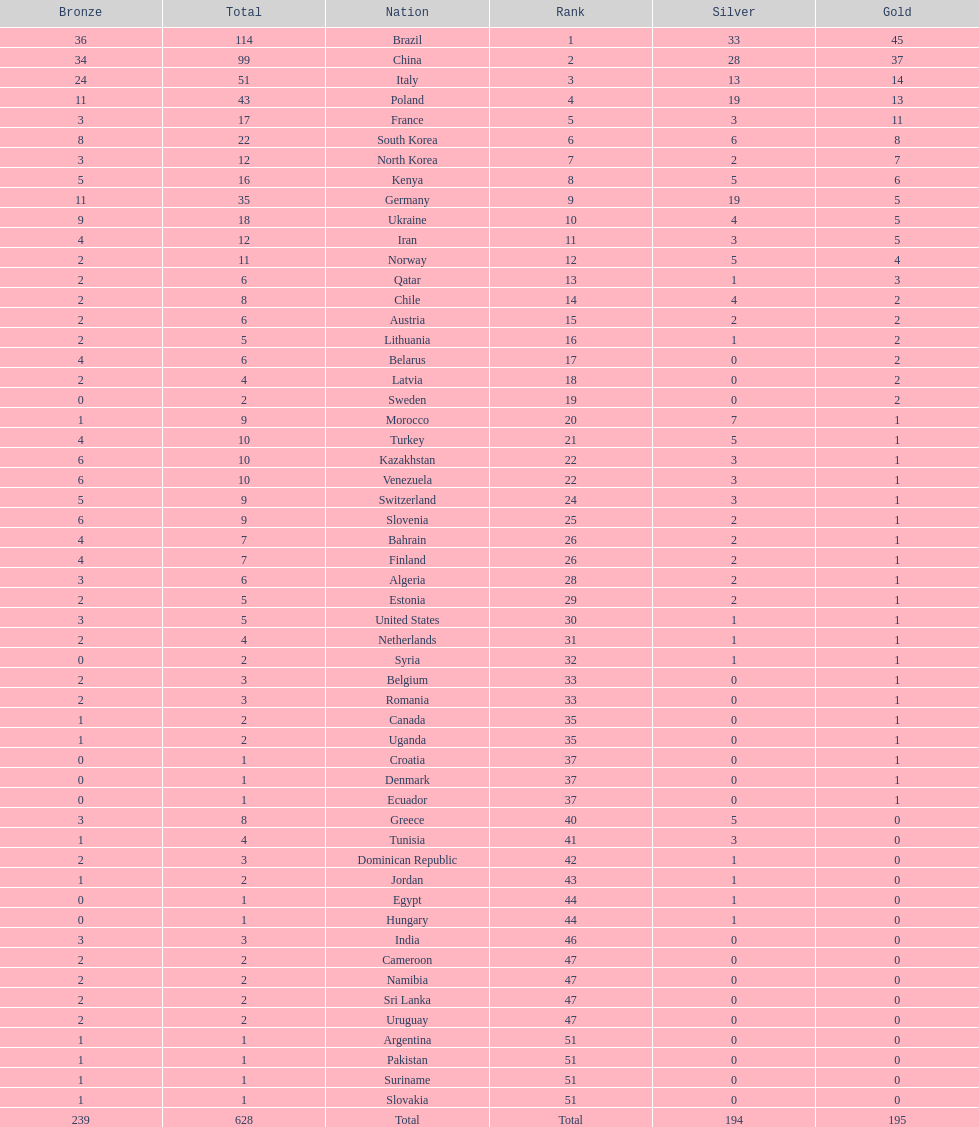Which nation earned the most gold medals? Brazil. 